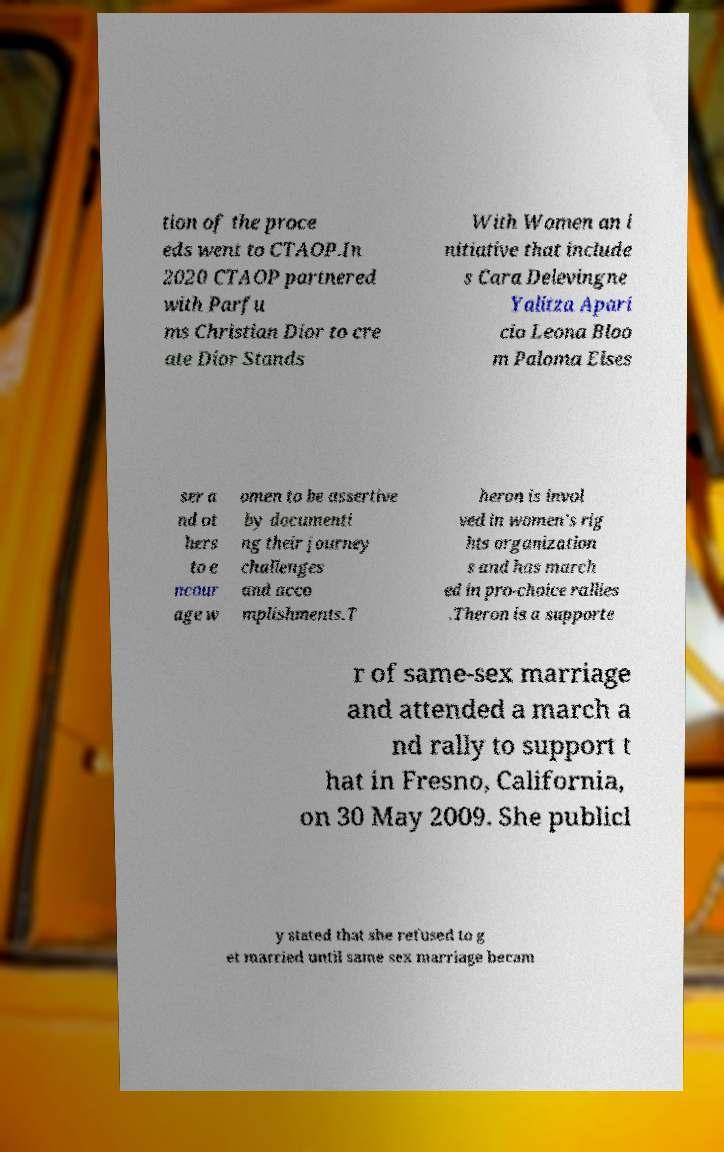Please read and relay the text visible in this image. What does it say? tion of the proce eds went to CTAOP.In 2020 CTAOP partnered with Parfu ms Christian Dior to cre ate Dior Stands With Women an i nitiative that include s Cara Delevingne Yalitza Apari cio Leona Bloo m Paloma Elses ser a nd ot hers to e ncour age w omen to be assertive by documenti ng their journey challenges and acco mplishments.T heron is invol ved in women's rig hts organization s and has march ed in pro-choice rallies .Theron is a supporte r of same-sex marriage and attended a march a nd rally to support t hat in Fresno, California, on 30 May 2009. She publicl y stated that she refused to g et married until same sex marriage becam 